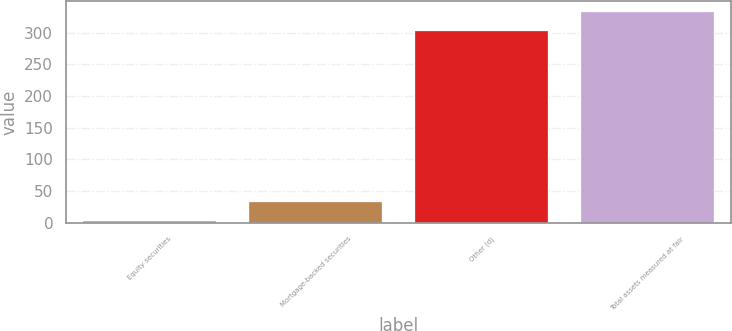Convert chart. <chart><loc_0><loc_0><loc_500><loc_500><bar_chart><fcel>Equity securities<fcel>Mortgage-backed securities<fcel>Other (d)<fcel>Total assets measured at fair<nl><fcel>2<fcel>32.8<fcel>302<fcel>332.8<nl></chart> 